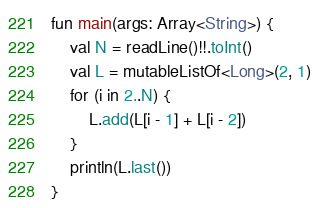<code> <loc_0><loc_0><loc_500><loc_500><_Kotlin_>fun main(args: Array<String>) {
    val N = readLine()!!.toInt()
    val L = mutableListOf<Long>(2, 1)
    for (i in 2..N) {
        L.add(L[i - 1] + L[i - 2])
    }
    println(L.last())
}

</code> 